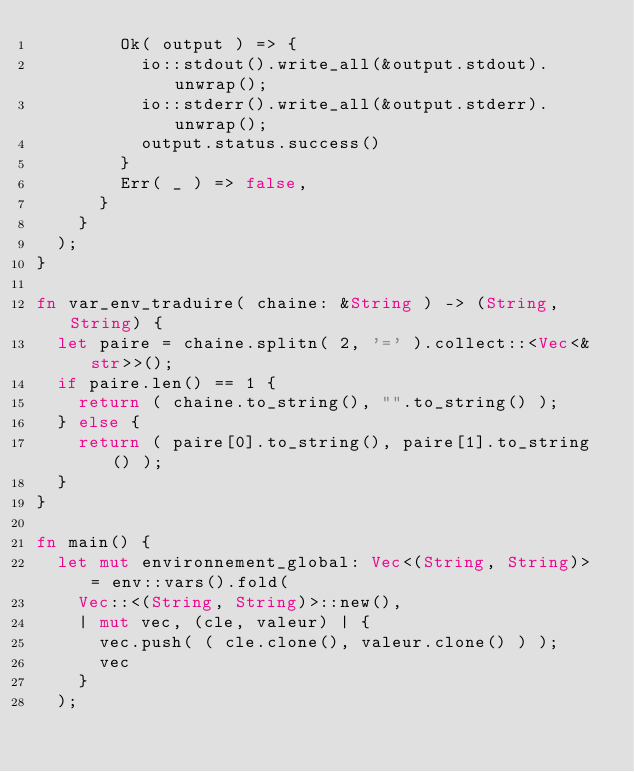<code> <loc_0><loc_0><loc_500><loc_500><_Rust_>        Ok( output ) => { 
          io::stdout().write_all(&output.stdout).unwrap();
          io::stderr().write_all(&output.stderr).unwrap(); 
          output.status.success() 
        }
        Err( _ ) => false, 
      }  
    } 
  ); 
} 

fn var_env_traduire( chaine: &String ) -> (String, String) { 
  let paire = chaine.splitn( 2, '=' ).collect::<Vec<&str>>(); 
  if paire.len() == 1 { 
    return ( chaine.to_string(), "".to_string() ); 
  } else { 
    return ( paire[0].to_string(), paire[1].to_string() ); 
  } 
}

fn main() { 
  let mut environnement_global: Vec<(String, String)> = env::vars().fold( 
    Vec::<(String, String)>::new(), 
    | mut vec, (cle, valeur) | { 
      vec.push( ( cle.clone(), valeur.clone() ) ); 
      vec 
    }  
  ); </code> 